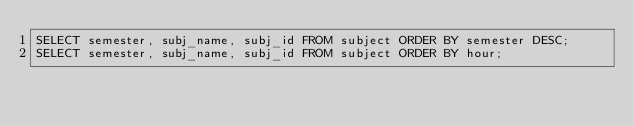Convert code to text. <code><loc_0><loc_0><loc_500><loc_500><_SQL_>SELECT semester, subj_name, subj_id FROM subject ORDER BY semester DESC;
SELECT semester, subj_name, subj_id FROM subject ORDER BY hour;</code> 